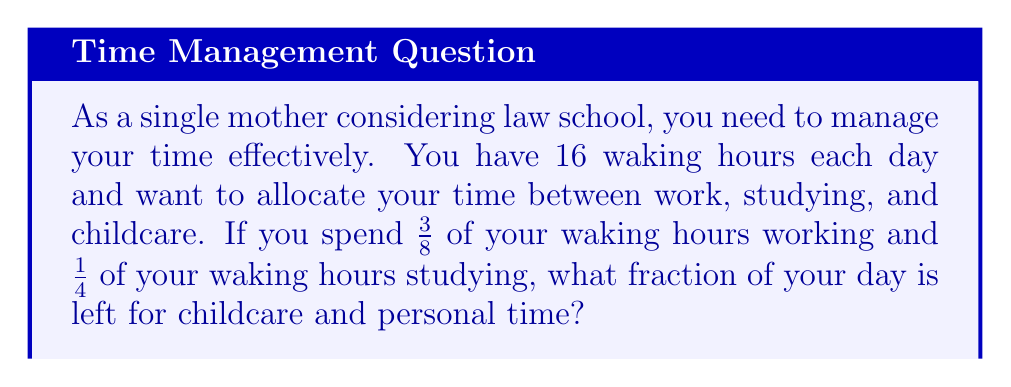Give your solution to this math problem. Let's approach this step-by-step:

1) First, we need to identify the total amount of time and the fractions already allocated:
   - Total waking hours: 16
   - Work: $\frac{3}{8}$ of waking hours
   - Study: $\frac{1}{4}$ of waking hours

2) To find the remaining time, we need to subtract the allocated fractions from the whole:
   $$1 - (\frac{3}{8} + \frac{1}{4})$$

3) Before we can subtract, we need to find a common denominator. The least common multiple of 8 and 4 is 8, so we'll use that:
   $$1 - (\frac{3}{8} + \frac{2}{8})$$

4) Now we can add the fractions inside the parentheses:
   $$1 - \frac{5}{8}$$

5) To subtract fractions, we need to convert 1 to a fraction with the same denominator:
   $$\frac{8}{8} - \frac{5}{8}$$

6) Now we can subtract:
   $$\frac{8}{8} - \frac{5}{8} = \frac{3}{8}$$

Therefore, $\frac{3}{8}$ of your waking hours are left for childcare and personal time.
Answer: $\frac{3}{8}$ 